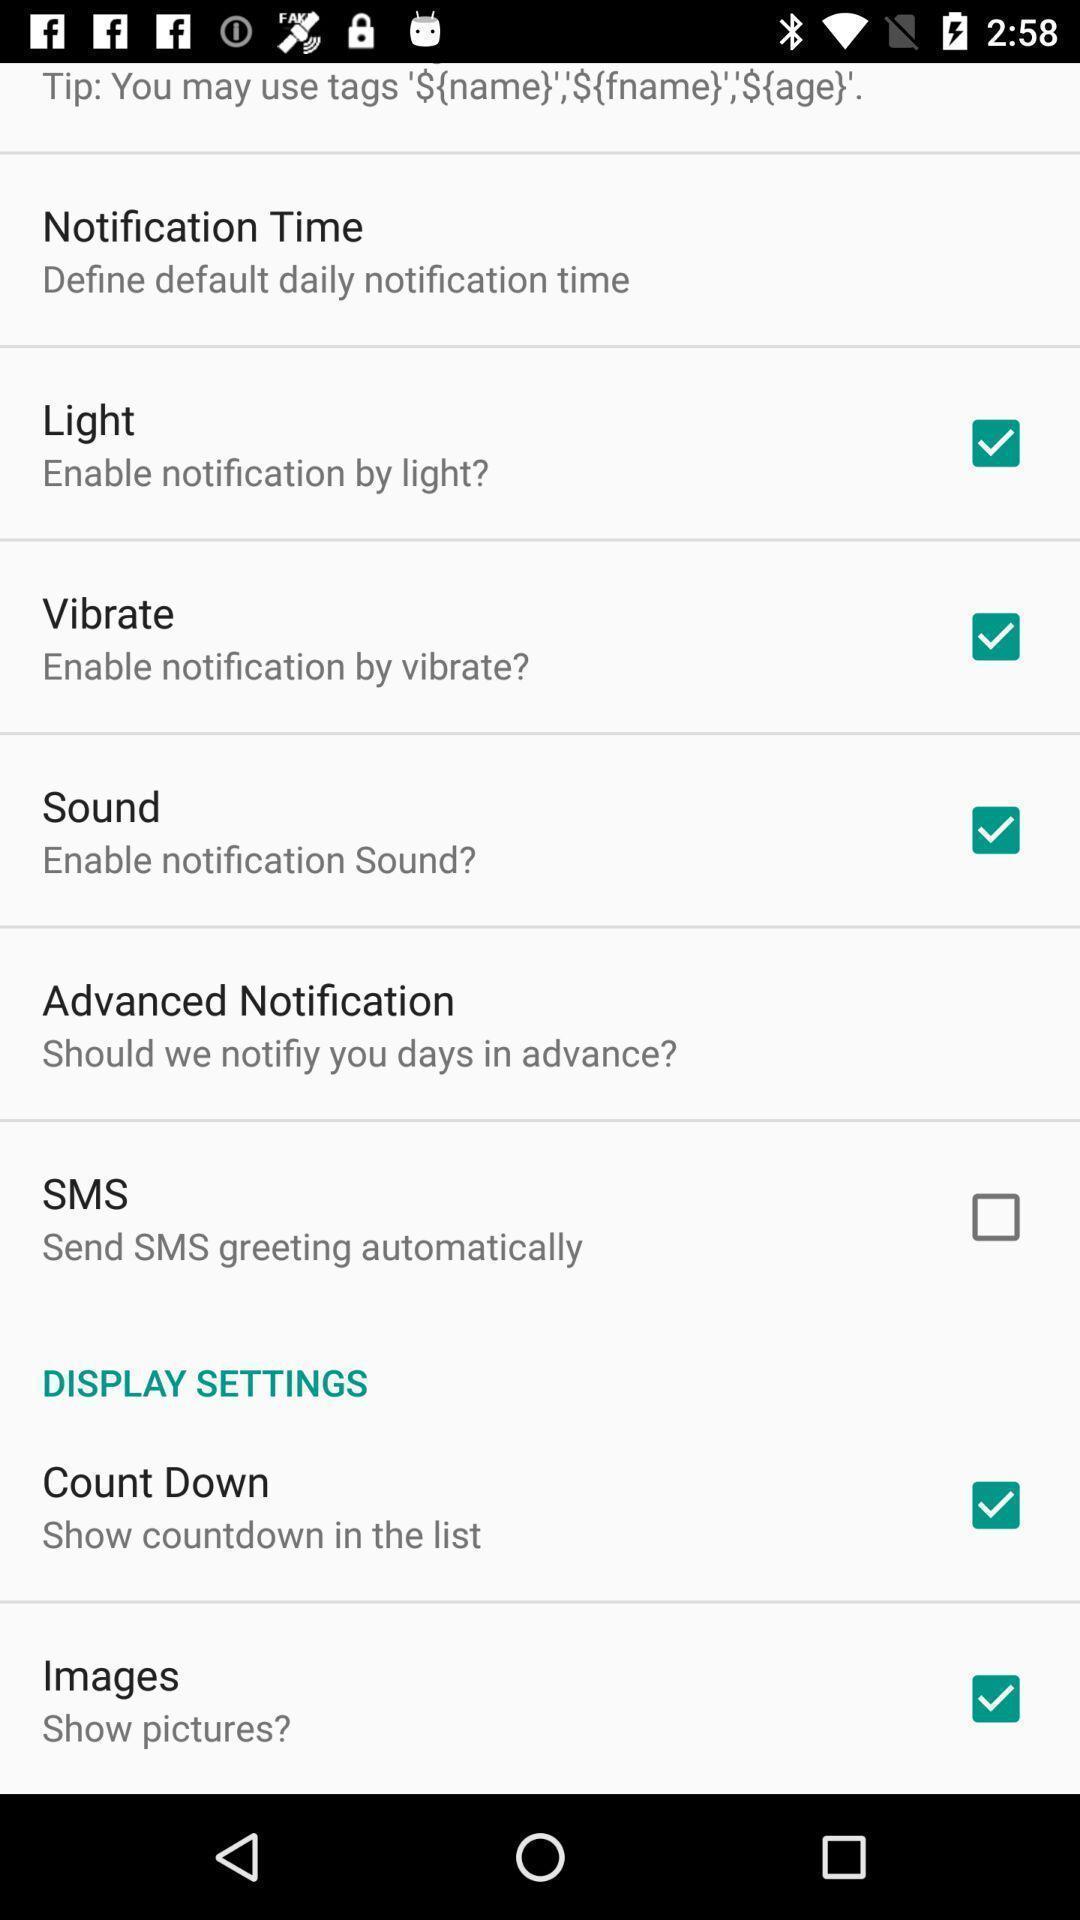Please provide a description for this image. Settings page displayed. 